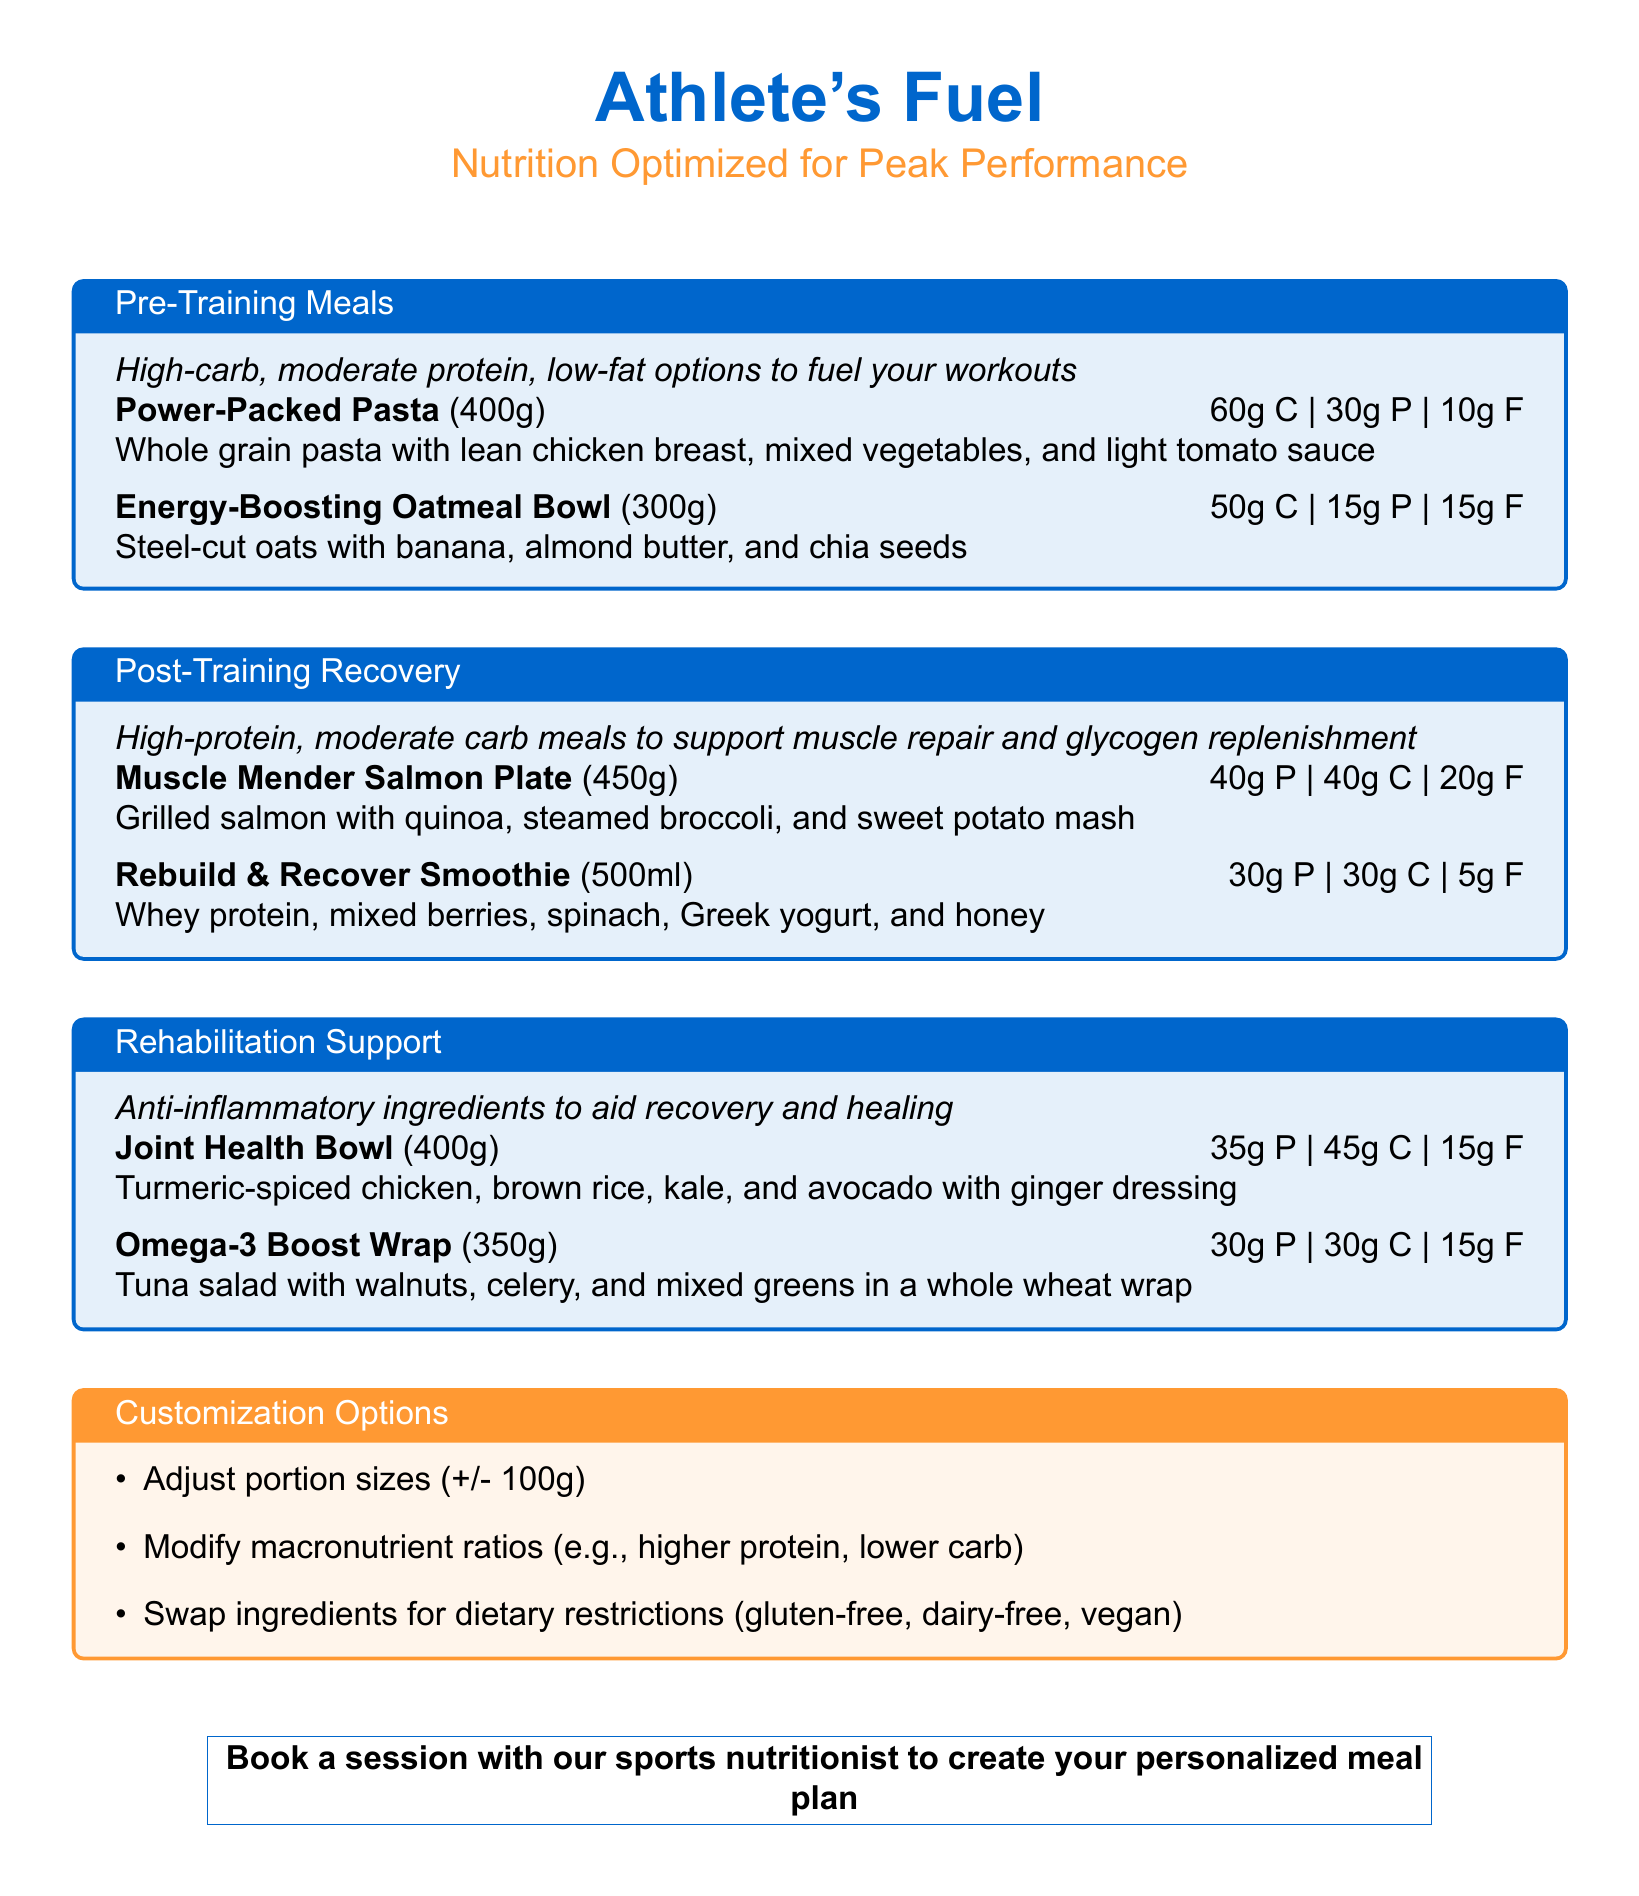What is the portion size of the Power-Packed Pasta? The portion size for the Power-Packed Pasta is 400g.
Answer: 400g How many grams of protein are in the Rebuild & Recover Smoothie? The Rebuild & Recover Smoothie contains 30g of protein.
Answer: 30g What type of meal do the meals in the Post-Training Recovery section primarily support? The meals in this section primarily support muscle repair and glycogen replenishment.
Answer: Muscle repair Which ingredient is used in the Joint Health Bowl for anti-inflammatory properties? Turmeric is used in the Joint Health Bowl for anti-inflammatory properties.
Answer: Turmeric How many customization options are listed in the document? There are three customization options listed in the document.
Answer: Three 